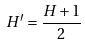Convert formula to latex. <formula><loc_0><loc_0><loc_500><loc_500>H ^ { \prime } = \frac { H + 1 } { 2 }</formula> 